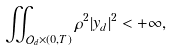Convert formula to latex. <formula><loc_0><loc_0><loc_500><loc_500>\iint _ { \mathcal { O } _ { d } \times ( 0 , T ) } \rho ^ { 2 } | y _ { d } | ^ { 2 } < + \infty ,</formula> 